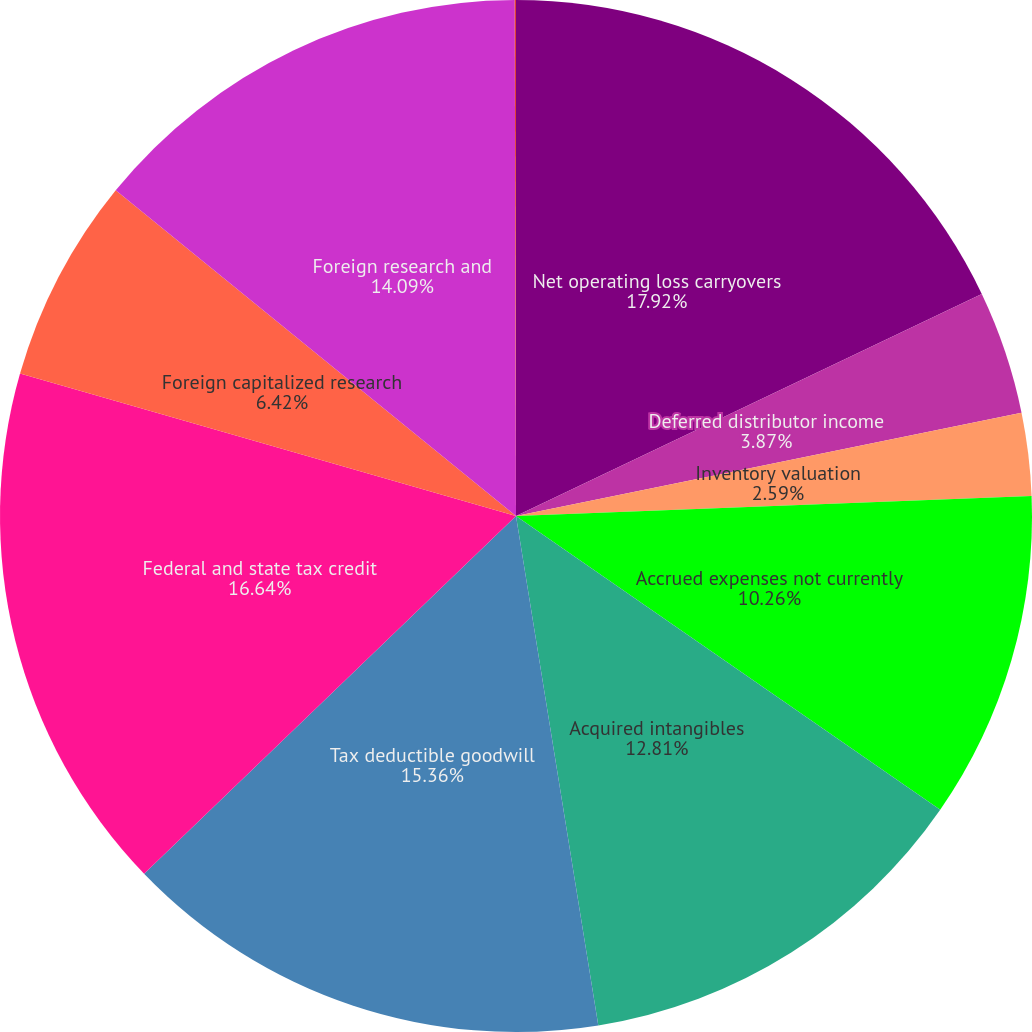<chart> <loc_0><loc_0><loc_500><loc_500><pie_chart><fcel>Net operating loss carryovers<fcel>Deferred distributor income<fcel>Inventory valuation<fcel>Accrued expenses not currently<fcel>Acquired intangibles<fcel>Tax deductible goodwill<fcel>Federal and state tax credit<fcel>Foreign capitalized research<fcel>Foreign research and<fcel>Discount of convertible notes<nl><fcel>17.92%<fcel>3.87%<fcel>2.59%<fcel>10.26%<fcel>12.81%<fcel>15.36%<fcel>16.64%<fcel>6.42%<fcel>14.09%<fcel>0.04%<nl></chart> 